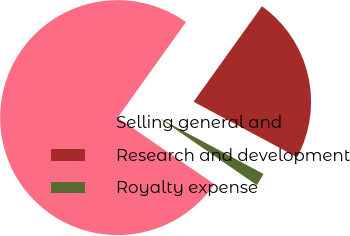Convert chart. <chart><loc_0><loc_0><loc_500><loc_500><pie_chart><fcel>Selling general and<fcel>Research and development<fcel>Royalty expense<nl><fcel>75.29%<fcel>22.94%<fcel>1.76%<nl></chart> 